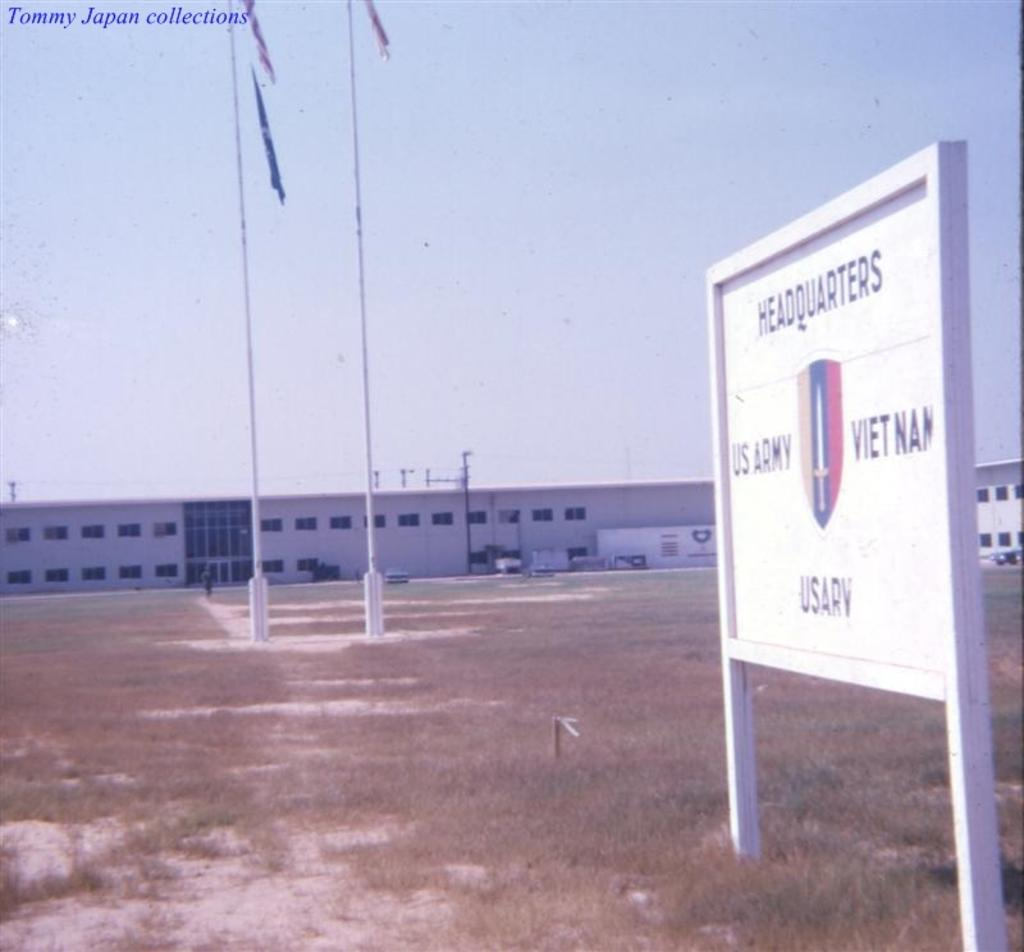<image>
Share a concise interpretation of the image provided. A sign identifies a low building as a US Army Headquarters location. 